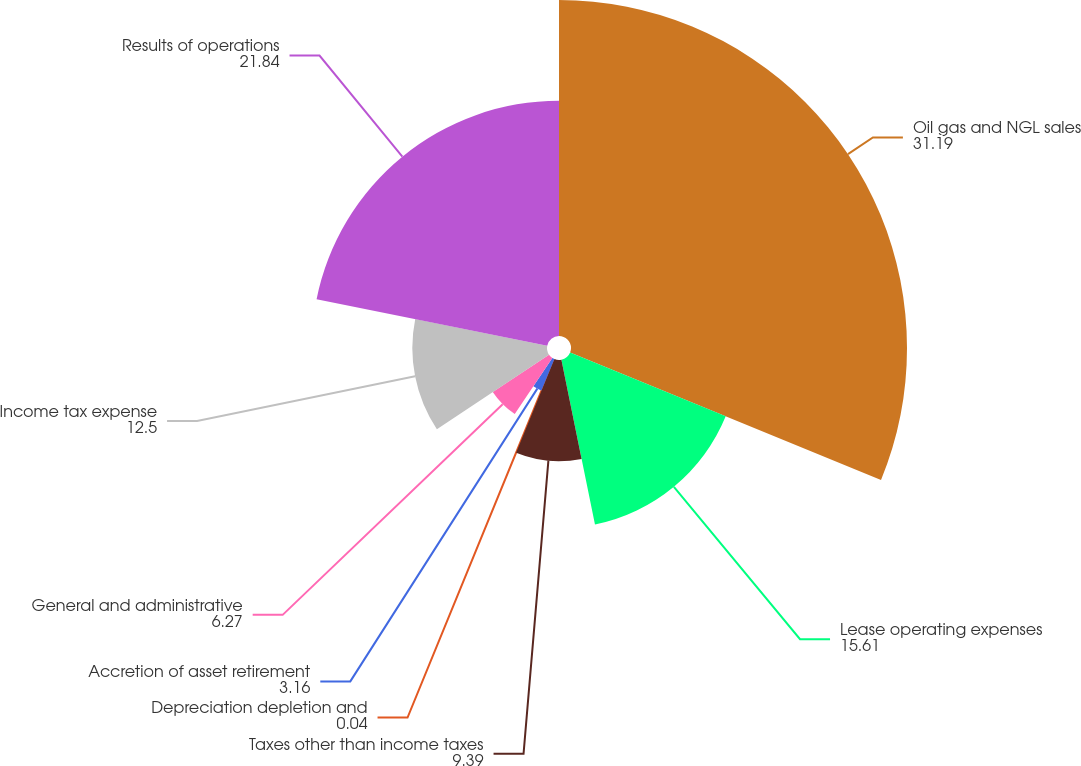Convert chart. <chart><loc_0><loc_0><loc_500><loc_500><pie_chart><fcel>Oil gas and NGL sales<fcel>Lease operating expenses<fcel>Taxes other than income taxes<fcel>Depreciation depletion and<fcel>Accretion of asset retirement<fcel>General and administrative<fcel>Income tax expense<fcel>Results of operations<nl><fcel>31.19%<fcel>15.61%<fcel>9.39%<fcel>0.04%<fcel>3.16%<fcel>6.27%<fcel>12.5%<fcel>21.84%<nl></chart> 